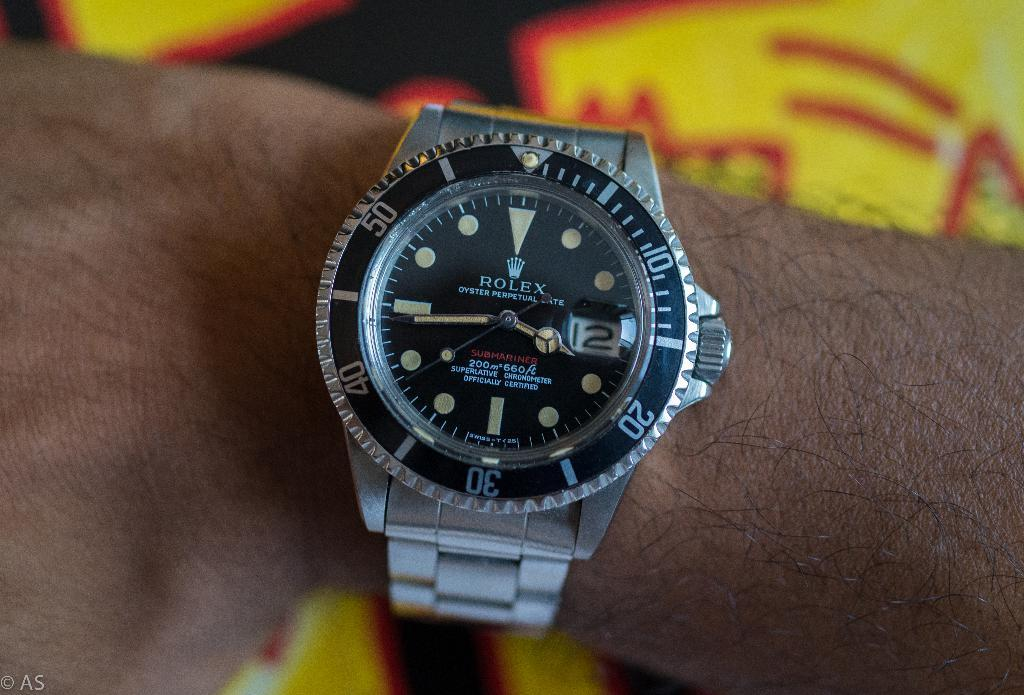<image>
Describe the image concisely. A silver Rolex Submariner displays the time 3:44. 